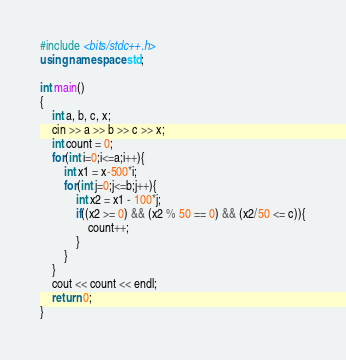<code> <loc_0><loc_0><loc_500><loc_500><_C++_>#include <bits/stdc++.h>
using namespace std;

int main()
{
    int a, b, c, x;
    cin >> a >> b >> c >> x;
    int count = 0;
    for(int i=0;i<=a;i++){
        int x1 = x-500*i;
        for(int j=0;j<=b;j++){
            int x2 = x1 - 100*j;
            if((x2 >= 0) && (x2 % 50 == 0) && (x2/50 <= c)){
                count++;
            }
        }
    }
    cout << count << endl;
    return 0;
}</code> 